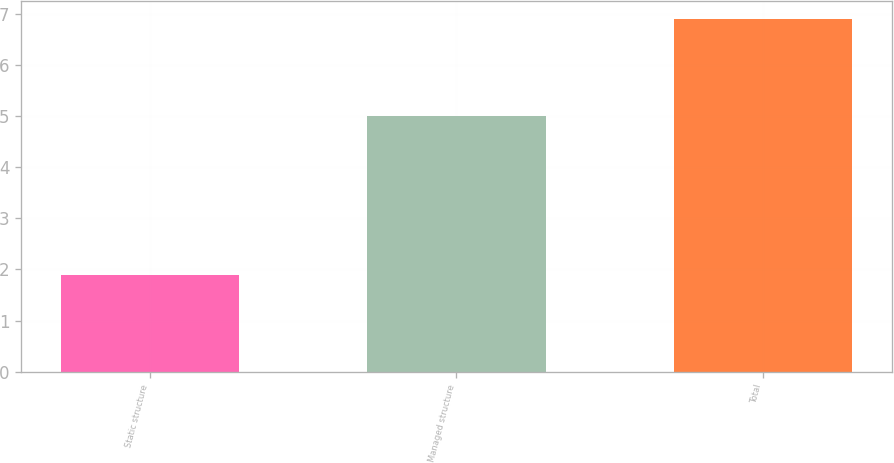Convert chart to OTSL. <chart><loc_0><loc_0><loc_500><loc_500><bar_chart><fcel>Static structure<fcel>Managed structure<fcel>Total<nl><fcel>1.9<fcel>5<fcel>6.9<nl></chart> 